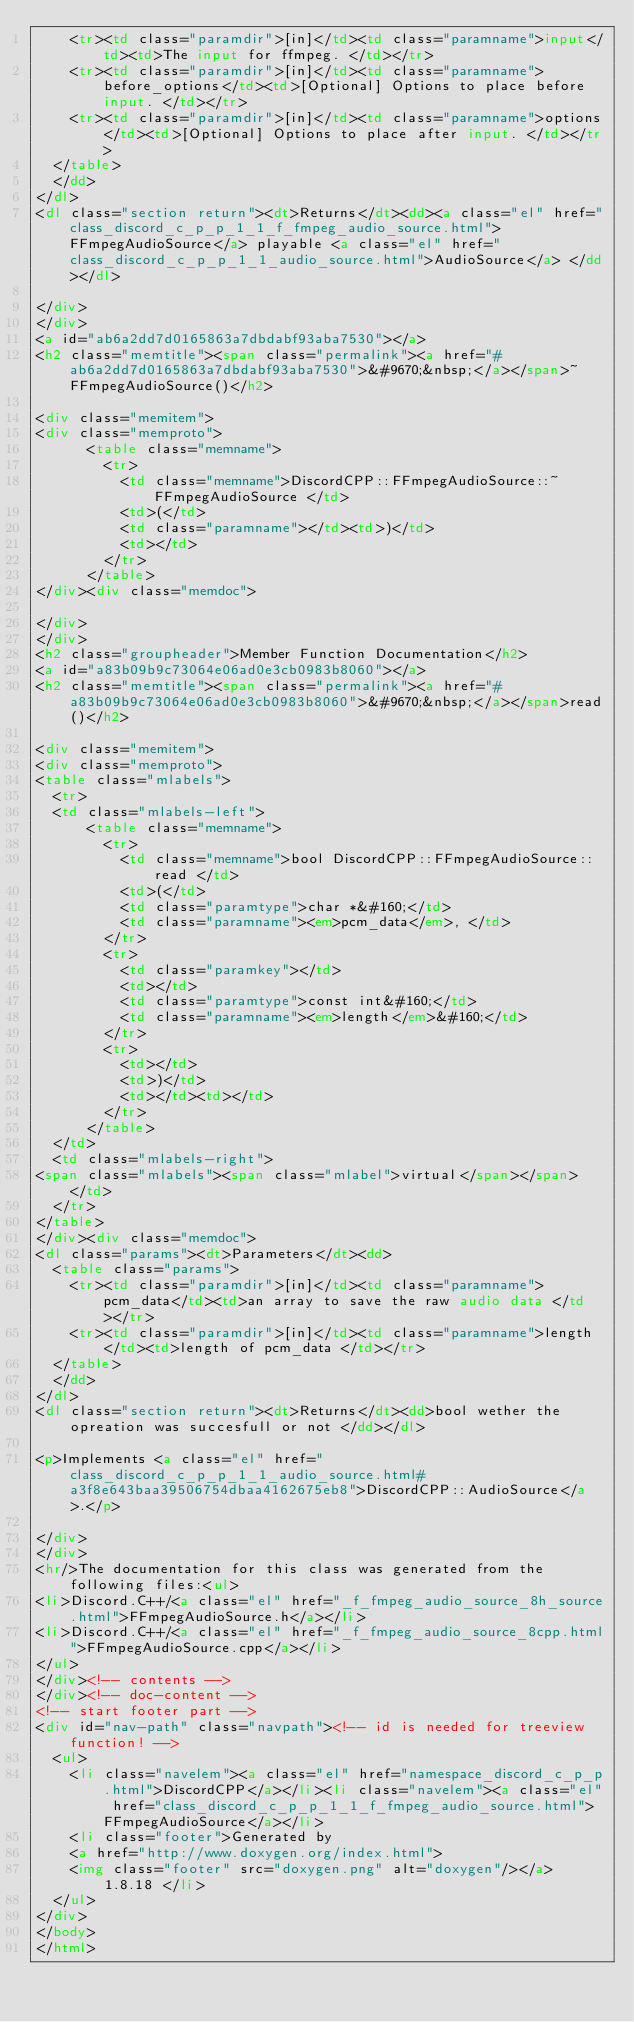<code> <loc_0><loc_0><loc_500><loc_500><_HTML_>    <tr><td class="paramdir">[in]</td><td class="paramname">input</td><td>The input for ffmpeg. </td></tr>
    <tr><td class="paramdir">[in]</td><td class="paramname">before_options</td><td>[Optional] Options to place before input. </td></tr>
    <tr><td class="paramdir">[in]</td><td class="paramname">options</td><td>[Optional] Options to place after input. </td></tr>
  </table>
  </dd>
</dl>
<dl class="section return"><dt>Returns</dt><dd><a class="el" href="class_discord_c_p_p_1_1_f_fmpeg_audio_source.html">FFmpegAudioSource</a> playable <a class="el" href="class_discord_c_p_p_1_1_audio_source.html">AudioSource</a> </dd></dl>

</div>
</div>
<a id="ab6a2dd7d0165863a7dbdabf93aba7530"></a>
<h2 class="memtitle"><span class="permalink"><a href="#ab6a2dd7d0165863a7dbdabf93aba7530">&#9670;&nbsp;</a></span>~FFmpegAudioSource()</h2>

<div class="memitem">
<div class="memproto">
      <table class="memname">
        <tr>
          <td class="memname">DiscordCPP::FFmpegAudioSource::~FFmpegAudioSource </td>
          <td>(</td>
          <td class="paramname"></td><td>)</td>
          <td></td>
        </tr>
      </table>
</div><div class="memdoc">

</div>
</div>
<h2 class="groupheader">Member Function Documentation</h2>
<a id="a83b09b9c73064e06ad0e3cb0983b8060"></a>
<h2 class="memtitle"><span class="permalink"><a href="#a83b09b9c73064e06ad0e3cb0983b8060">&#9670;&nbsp;</a></span>read()</h2>

<div class="memitem">
<div class="memproto">
<table class="mlabels">
  <tr>
  <td class="mlabels-left">
      <table class="memname">
        <tr>
          <td class="memname">bool DiscordCPP::FFmpegAudioSource::read </td>
          <td>(</td>
          <td class="paramtype">char *&#160;</td>
          <td class="paramname"><em>pcm_data</em>, </td>
        </tr>
        <tr>
          <td class="paramkey"></td>
          <td></td>
          <td class="paramtype">const int&#160;</td>
          <td class="paramname"><em>length</em>&#160;</td>
        </tr>
        <tr>
          <td></td>
          <td>)</td>
          <td></td><td></td>
        </tr>
      </table>
  </td>
  <td class="mlabels-right">
<span class="mlabels"><span class="mlabel">virtual</span></span>  </td>
  </tr>
</table>
</div><div class="memdoc">
<dl class="params"><dt>Parameters</dt><dd>
  <table class="params">
    <tr><td class="paramdir">[in]</td><td class="paramname">pcm_data</td><td>an array to save the raw audio data </td></tr>
    <tr><td class="paramdir">[in]</td><td class="paramname">length</td><td>length of pcm_data </td></tr>
  </table>
  </dd>
</dl>
<dl class="section return"><dt>Returns</dt><dd>bool wether the opreation was succesfull or not </dd></dl>

<p>Implements <a class="el" href="class_discord_c_p_p_1_1_audio_source.html#a3f8e643baa39506754dbaa4162675eb8">DiscordCPP::AudioSource</a>.</p>

</div>
</div>
<hr/>The documentation for this class was generated from the following files:<ul>
<li>Discord.C++/<a class="el" href="_f_fmpeg_audio_source_8h_source.html">FFmpegAudioSource.h</a></li>
<li>Discord.C++/<a class="el" href="_f_fmpeg_audio_source_8cpp.html">FFmpegAudioSource.cpp</a></li>
</ul>
</div><!-- contents -->
</div><!-- doc-content -->
<!-- start footer part -->
<div id="nav-path" class="navpath"><!-- id is needed for treeview function! -->
  <ul>
    <li class="navelem"><a class="el" href="namespace_discord_c_p_p.html">DiscordCPP</a></li><li class="navelem"><a class="el" href="class_discord_c_p_p_1_1_f_fmpeg_audio_source.html">FFmpegAudioSource</a></li>
    <li class="footer">Generated by
    <a href="http://www.doxygen.org/index.html">
    <img class="footer" src="doxygen.png" alt="doxygen"/></a> 1.8.18 </li>
  </ul>
</div>
</body>
</html>
</code> 